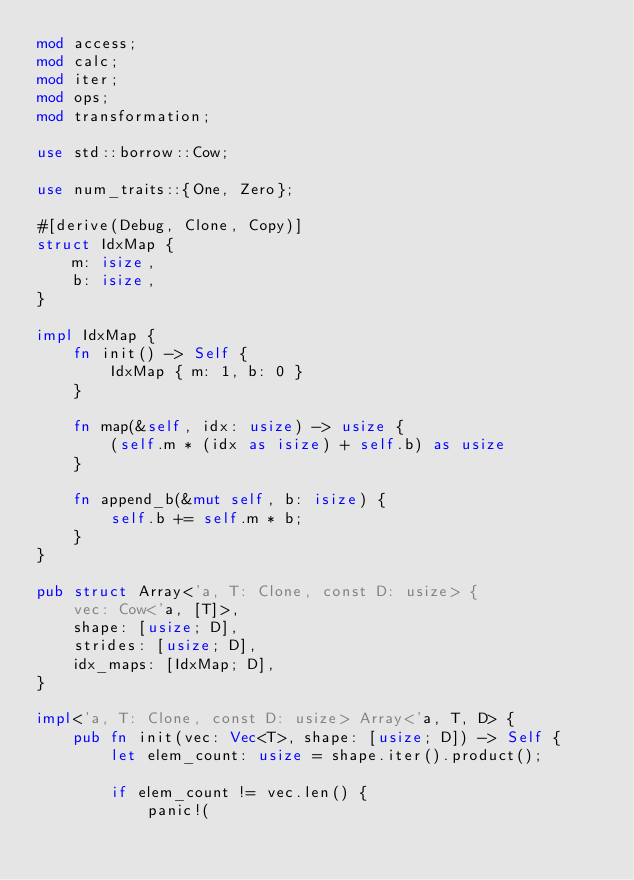Convert code to text. <code><loc_0><loc_0><loc_500><loc_500><_Rust_>mod access;
mod calc;
mod iter;
mod ops;
mod transformation;

use std::borrow::Cow;

use num_traits::{One, Zero};

#[derive(Debug, Clone, Copy)]
struct IdxMap {
    m: isize,
    b: isize,
}

impl IdxMap {
    fn init() -> Self {
        IdxMap { m: 1, b: 0 }
    }

    fn map(&self, idx: usize) -> usize {
        (self.m * (idx as isize) + self.b) as usize
    }

    fn append_b(&mut self, b: isize) {
        self.b += self.m * b;
    }
}

pub struct Array<'a, T: Clone, const D: usize> {
    vec: Cow<'a, [T]>,
    shape: [usize; D],
    strides: [usize; D],
    idx_maps: [IdxMap; D],
}

impl<'a, T: Clone, const D: usize> Array<'a, T, D> {
    pub fn init(vec: Vec<T>, shape: [usize; D]) -> Self {
        let elem_count: usize = shape.iter().product();

        if elem_count != vec.len() {
            panic!(</code> 